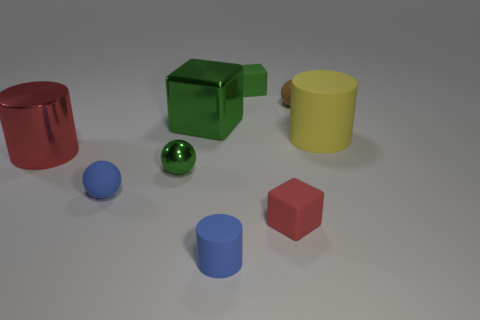There is a ball that is the same color as the big block; what is its material?
Offer a terse response. Metal. How many objects are either blue cylinders or yellow rubber things?
Your response must be concise. 2. Do the tiny green thing on the right side of the tiny shiny object and the red cube have the same material?
Your answer should be very brief. Yes. The shiny sphere has what size?
Give a very brief answer. Small. What is the shape of the matte thing that is the same color as the big shiny block?
Offer a terse response. Cube. What number of cylinders are either yellow rubber objects or big objects?
Your answer should be compact. 2. Are there the same number of large shiny cylinders in front of the tiny green metal sphere and blue cylinders that are left of the blue cylinder?
Keep it short and to the point. Yes. The blue matte thing that is the same shape as the yellow matte object is what size?
Provide a succinct answer. Small. How big is the object that is in front of the large yellow thing and right of the green rubber block?
Provide a short and direct response. Small. Are there any big cylinders on the left side of the small brown rubber thing?
Make the answer very short. Yes. 